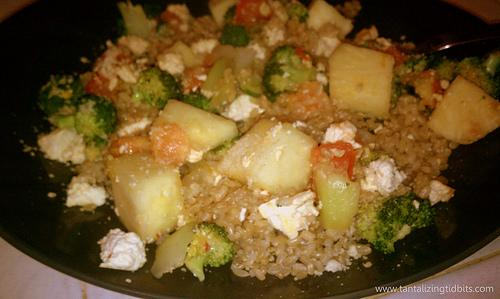What type of dish is being served on the plate? A rice dish with broccoli, tomato, chicken, pineapple, and crumbled cheese. Identify the primary object in the image and provide its color and shape. The primary object is a black, round plate. How many different food items are there on the plate? There are six food items on the plate. Analyze the interaction between the chicken and the pineapple in the dish. The chicken pieces are placed on top of the pineapple, creating a tasty combination of flavors. List three objects in the image and their respective locations. Broccoli is on the plate, the silverware is in the corner and a URL is in another corner. Formulate a complex reasoning question regarding the information in the image. Considering the various food items, how does the combination of flavors impact the overall culinary experience of this dish for the diner? What type of object is found near the corner of the image and what does it represent? The object is a URL or website address which implies it's related to the meal or its source. Describe how the silverware is positioned in the image. The silverware, including a spoon and perhaps other utensils, is placed on the plate with the handles aligned in the corner. Mention the primary sentiment that arises from looking at the image. The primary sentiment is satisfaction from a delicious and visually appealing meal. Provide a brief description of the overall quality of the image. The image is of high quality with clear and detailed object representations and proper annotations. Describe the main object on the image. There is a round black plate with a rice dish containing broccoli, chicken, pineapple, and tomato. Is the website mentioned www.deliciousdishes.com? The actual website mentioned is wwwtantalizingtidbitscom, not www.deliciousdishes.com. Find the sentiment depicted by the presentation of the dinner on the black plate. Is it positive or negative? Positive Is the plate on a wooden surface? The plate is on a white countertop, not a wooden surface. Rate the arrangement of the food items on the black plate on a scale from 1 to 5, with 5 being the best arrangement. 3 Explain the interaction between the chicken pieces and pineapple in the image. Chicken pieces are placed on top of pineapple slices. Which object has the coordinates X:1 Y:222 Width:60 Height:60? An edge of a plate Describe the color and shape of the food placed on top of the pineapple. Red and chunky Which part of the plate has crumbled cheese on it? Top right corner of the plate Is the website mentioned in the image written conventionally or is there a typographical error? Typographical error Are there strawberries on the rice dish? There are broccoli, crumbled cheese, tomato, pineapples, and chicken mentioned on the plate, but no strawberries. Rate the image quality on a scale from 1 to 5, with 5 being the highest quality. 4 Is the plate blue and square? The plate is actually black and round, not blue and square. What type of utensil can be seen on the plate in the image? A spoon Are there any unusual elements in the image? Yes, the url wwwtantalizingtidbitscom is printed on the image. Read and provide the website listed at the bottom of the image. wwwtantalizingtidbitscom Determine the position of the silverware in relation to the plate. The silverware is on the plate, near the top-left corner. Can you find green lettuce on the plate? There are different types of food mentioned on the plate, but no green lettuce is mentioned. Is there a fork on the plate? No, it's not mentioned in the image. What color is the plate in the image with the coordinates X:4 Y:16 Width:456 Height:456? Black What is the shape of the plate in the image? Round Connect an object in the image with a specific description from the provided captions. Edge of a spoon matches with the coordinates X:431 Y:41 Width:32 Height:32. Which food item is the most visible on the plate in the image? b) pineapple Identify the main object in the image with the coordinates X:11 Y:68 Width:395 Height:395. The plate is black and round. What is the primary function of the object with coordinates X:431 Y:41 Width:32 Height:32? Utensil for eating 